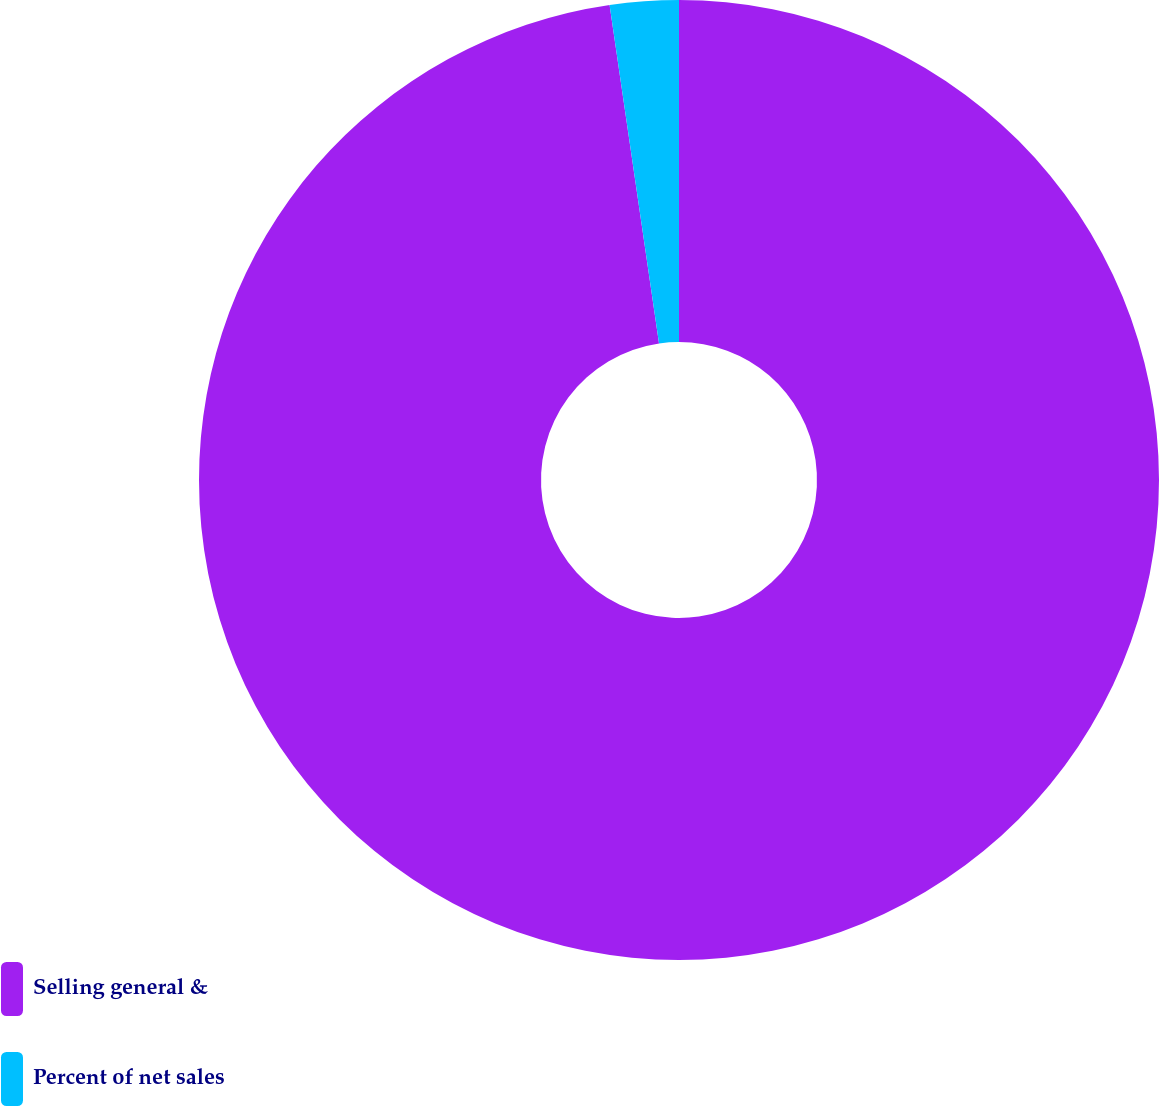Convert chart. <chart><loc_0><loc_0><loc_500><loc_500><pie_chart><fcel>Selling general &<fcel>Percent of net sales<nl><fcel>97.69%<fcel>2.31%<nl></chart> 